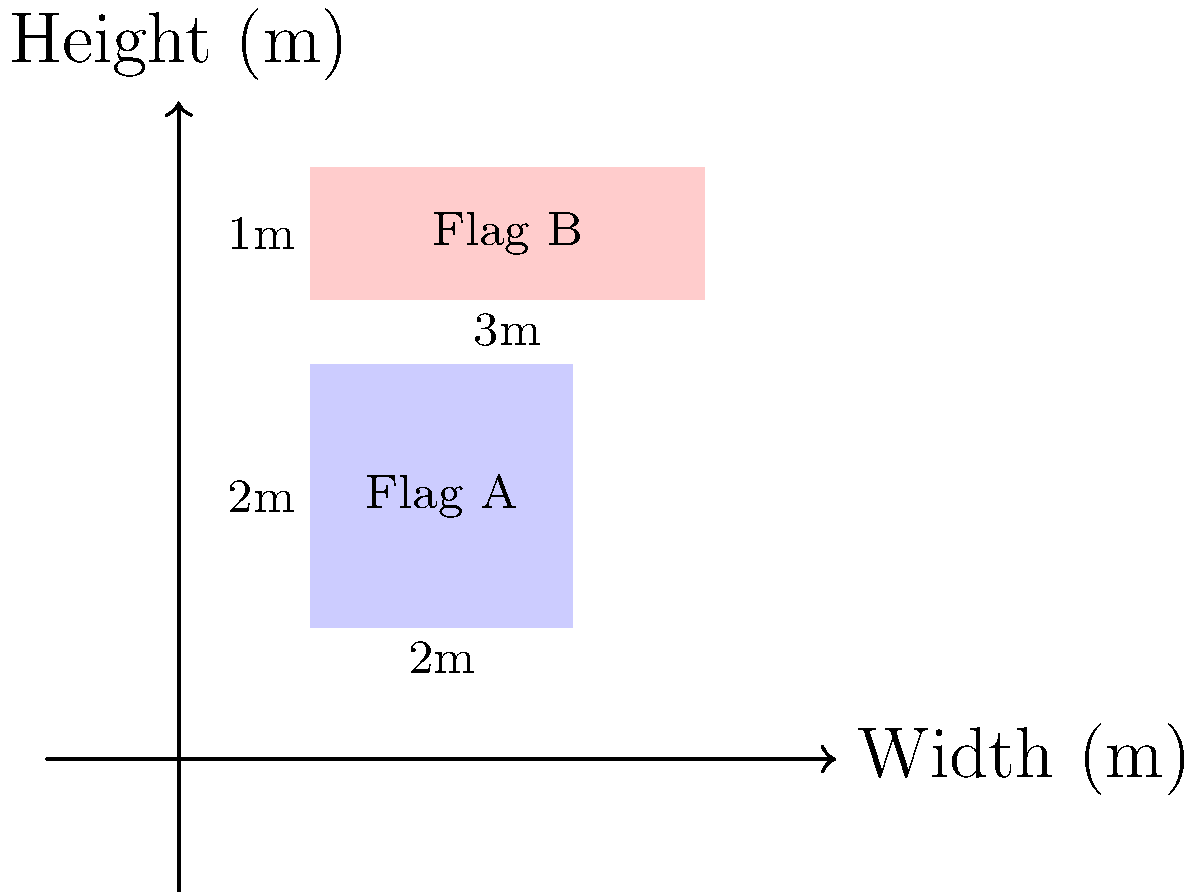As a retired graphic designer creating custom flags, you're asked to design two flags for a windy outdoor event. Flag A is a square with sides of 2 meters, while Flag B is a rectangle measuring 3 meters wide and 1 meter high. If the wind force $F$ on a flag is given by the equation $F = \frac{1}{2}\rho v^2 A C_d$, where $\rho$ is the air density (1.225 kg/m³), $v$ is the wind velocity (10 m/s), $A$ is the flag area, and $C_d$ is the drag coefficient (assume 1.2 for both flags), calculate the difference in wind force between Flag B and Flag A. To solve this problem, we'll follow these steps:

1. Calculate the area of each flag:
   Flag A: $A_A = 2\text{ m} \times 2\text{ m} = 4\text{ m}^2$
   Flag B: $A_B = 3\text{ m} \times 1\text{ m} = 3\text{ m}^2$

2. Use the given equation to calculate the wind force on each flag:
   $F = \frac{1}{2}\rho v^2 A C_d$

   For Flag A:
   $F_A = \frac{1}{2} \times 1.225\text{ kg/m}^3 \times (10\text{ m/s})^2 \times 4\text{ m}^2 \times 1.2$
   $F_A = 294\text{ N}$

   For Flag B:
   $F_B = \frac{1}{2} \times 1.225\text{ kg/m}^3 \times (10\text{ m/s})^2 \times 3\text{ m}^2 \times 1.2$
   $F_B = 220.5\text{ N}$

3. Calculate the difference in wind force:
   $\Delta F = F_B - F_A = 220.5\text{ N} - 294\text{ N} = -73.5\text{ N}$

The negative value indicates that the wind force on Flag B is less than on Flag A.
Answer: $-73.5\text{ N}$ 